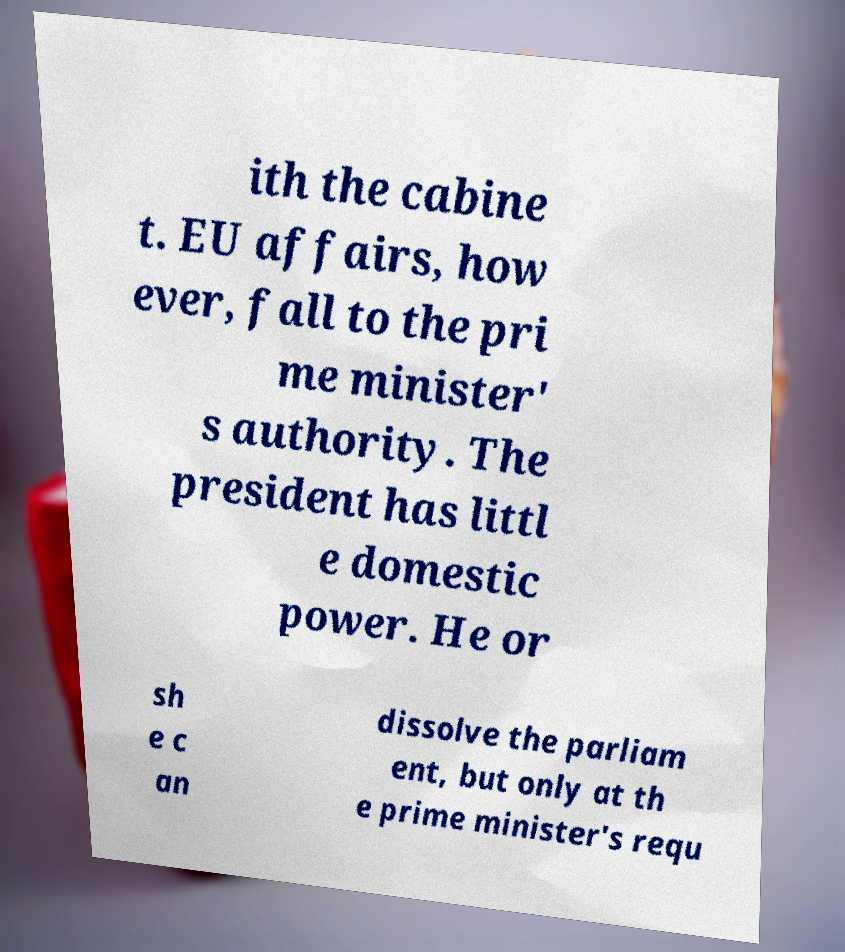What messages or text are displayed in this image? I need them in a readable, typed format. ith the cabine t. EU affairs, how ever, fall to the pri me minister' s authority. The president has littl e domestic power. He or sh e c an dissolve the parliam ent, but only at th e prime minister's requ 